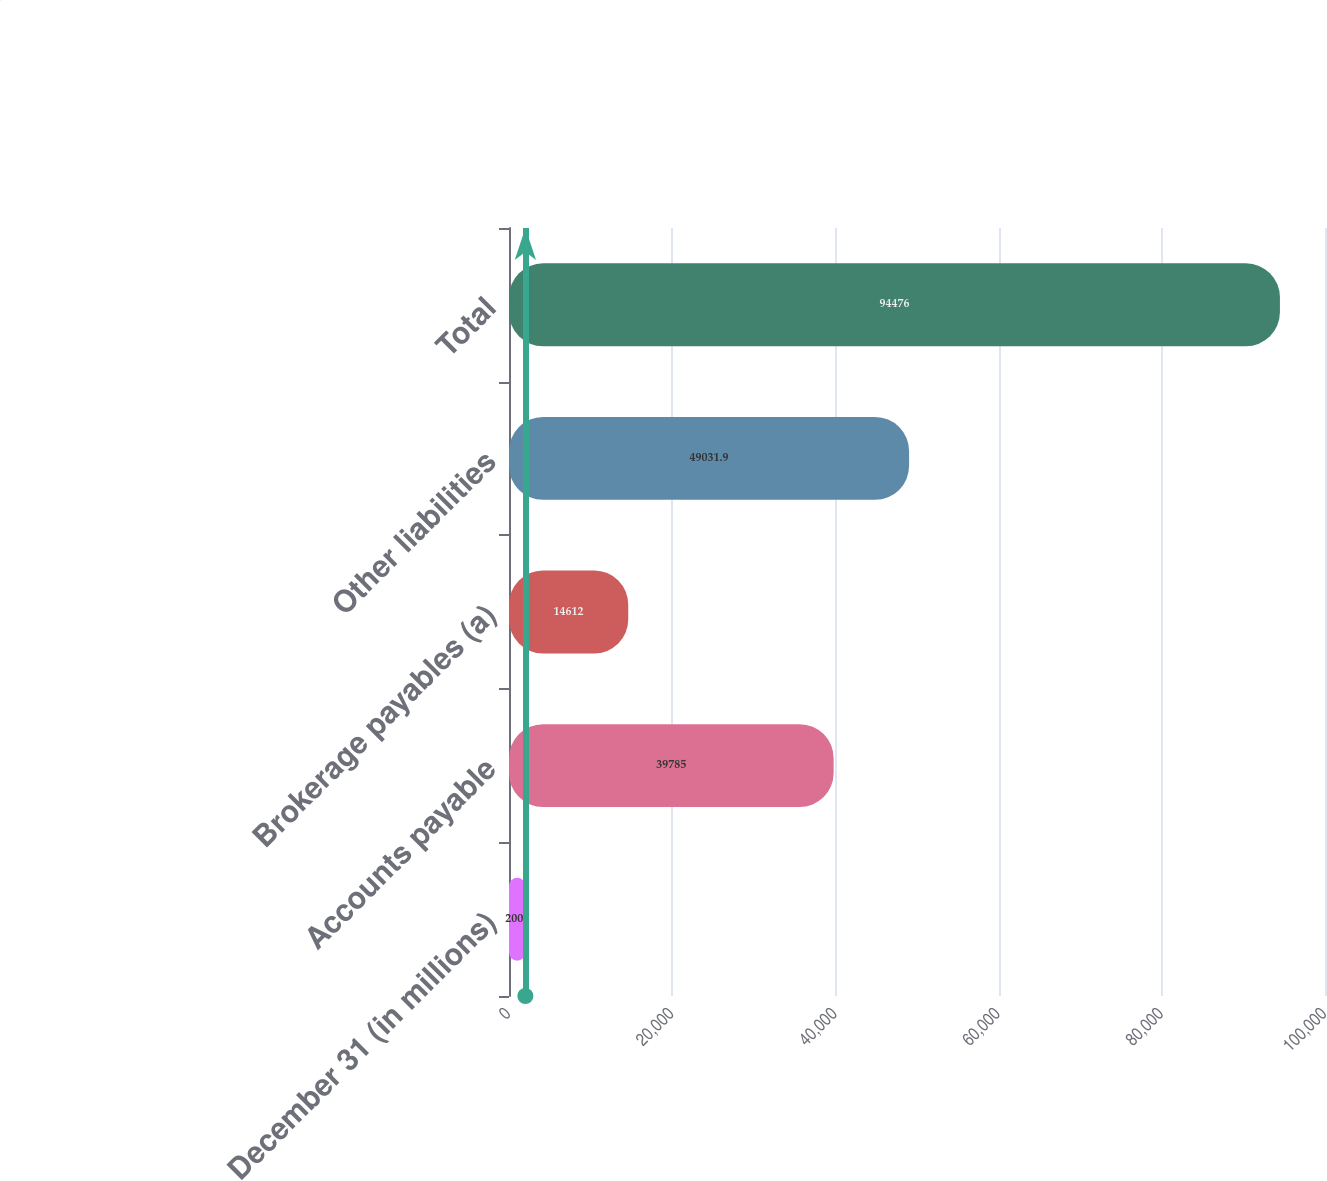Convert chart. <chart><loc_0><loc_0><loc_500><loc_500><bar_chart><fcel>December 31 (in millions)<fcel>Accounts payable<fcel>Brokerage payables (a)<fcel>Other liabilities<fcel>Total<nl><fcel>2007<fcel>39785<fcel>14612<fcel>49031.9<fcel>94476<nl></chart> 